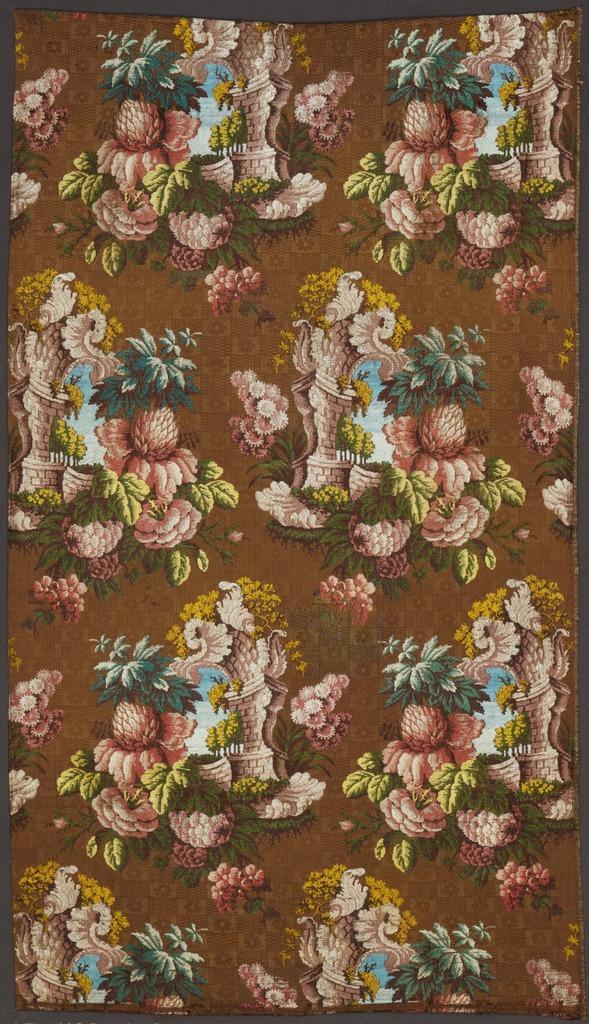In one or two sentences, can you explain what this image depicts? In this image there is a photo frame, the background of the frame is brown in color, there are different objects in the photo frame. 